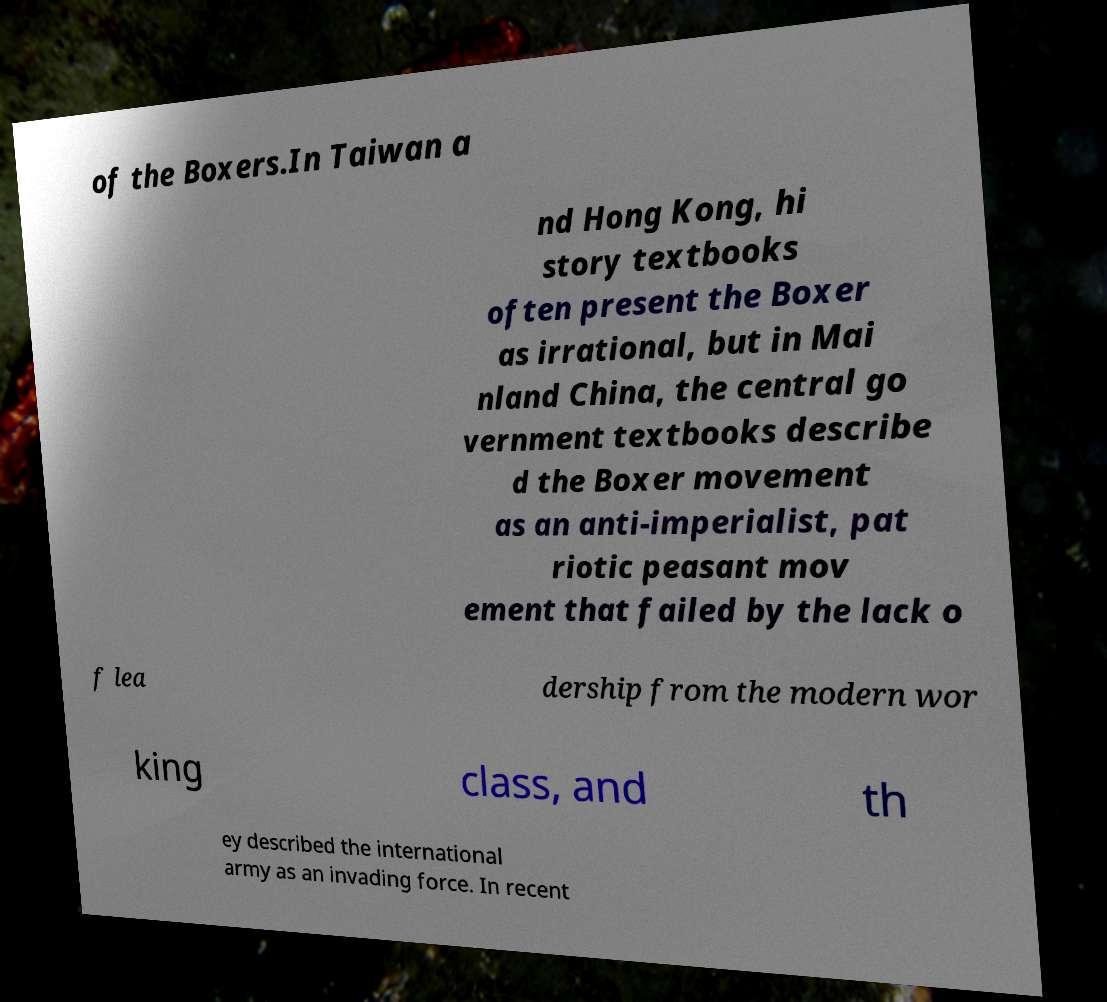What messages or text are displayed in this image? I need them in a readable, typed format. of the Boxers.In Taiwan a nd Hong Kong, hi story textbooks often present the Boxer as irrational, but in Mai nland China, the central go vernment textbooks describe d the Boxer movement as an anti-imperialist, pat riotic peasant mov ement that failed by the lack o f lea dership from the modern wor king class, and th ey described the international army as an invading force. In recent 